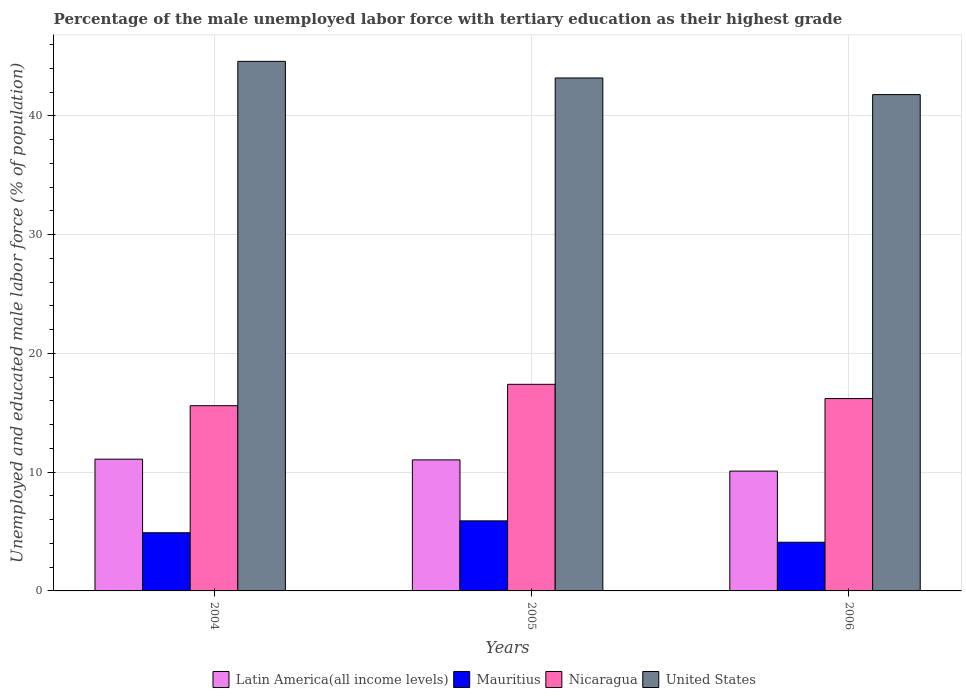How many different coloured bars are there?
Ensure brevity in your answer.  4. How many groups of bars are there?
Offer a very short reply. 3. How many bars are there on the 2nd tick from the left?
Provide a succinct answer. 4. What is the percentage of the unemployed male labor force with tertiary education in Mauritius in 2005?
Ensure brevity in your answer.  5.9. Across all years, what is the maximum percentage of the unemployed male labor force with tertiary education in Nicaragua?
Your answer should be compact. 17.4. Across all years, what is the minimum percentage of the unemployed male labor force with tertiary education in United States?
Keep it short and to the point. 41.8. In which year was the percentage of the unemployed male labor force with tertiary education in Mauritius minimum?
Your answer should be compact. 2006. What is the total percentage of the unemployed male labor force with tertiary education in Mauritius in the graph?
Your answer should be very brief. 14.9. What is the difference between the percentage of the unemployed male labor force with tertiary education in United States in 2005 and that in 2006?
Offer a very short reply. 1.4. What is the difference between the percentage of the unemployed male labor force with tertiary education in United States in 2005 and the percentage of the unemployed male labor force with tertiary education in Nicaragua in 2004?
Your answer should be compact. 27.6. What is the average percentage of the unemployed male labor force with tertiary education in Latin America(all income levels) per year?
Provide a succinct answer. 10.74. In the year 2006, what is the difference between the percentage of the unemployed male labor force with tertiary education in Mauritius and percentage of the unemployed male labor force with tertiary education in Nicaragua?
Make the answer very short. -12.1. In how many years, is the percentage of the unemployed male labor force with tertiary education in Latin America(all income levels) greater than 32 %?
Offer a very short reply. 0. What is the ratio of the percentage of the unemployed male labor force with tertiary education in United States in 2005 to that in 2006?
Provide a succinct answer. 1.03. Is the percentage of the unemployed male labor force with tertiary education in Mauritius in 2004 less than that in 2006?
Your answer should be compact. No. What is the difference between the highest and the second highest percentage of the unemployed male labor force with tertiary education in United States?
Your response must be concise. 1.4. What is the difference between the highest and the lowest percentage of the unemployed male labor force with tertiary education in Latin America(all income levels)?
Offer a terse response. 1. In how many years, is the percentage of the unemployed male labor force with tertiary education in United States greater than the average percentage of the unemployed male labor force with tertiary education in United States taken over all years?
Your answer should be very brief. 2. Is the sum of the percentage of the unemployed male labor force with tertiary education in United States in 2004 and 2006 greater than the maximum percentage of the unemployed male labor force with tertiary education in Nicaragua across all years?
Make the answer very short. Yes. Is it the case that in every year, the sum of the percentage of the unemployed male labor force with tertiary education in Latin America(all income levels) and percentage of the unemployed male labor force with tertiary education in Mauritius is greater than the sum of percentage of the unemployed male labor force with tertiary education in United States and percentage of the unemployed male labor force with tertiary education in Nicaragua?
Offer a very short reply. No. What does the 1st bar from the left in 2004 represents?
Make the answer very short. Latin America(all income levels). What does the 3rd bar from the right in 2005 represents?
Provide a succinct answer. Mauritius. Are all the bars in the graph horizontal?
Give a very brief answer. No. How many years are there in the graph?
Offer a terse response. 3. Does the graph contain any zero values?
Offer a very short reply. No. Where does the legend appear in the graph?
Make the answer very short. Bottom center. How are the legend labels stacked?
Provide a succinct answer. Horizontal. What is the title of the graph?
Give a very brief answer. Percentage of the male unemployed labor force with tertiary education as their highest grade. Does "Middle East & North Africa (all income levels)" appear as one of the legend labels in the graph?
Keep it short and to the point. No. What is the label or title of the X-axis?
Your answer should be compact. Years. What is the label or title of the Y-axis?
Your answer should be very brief. Unemployed and educated male labor force (% of population). What is the Unemployed and educated male labor force (% of population) in Latin America(all income levels) in 2004?
Provide a short and direct response. 11.1. What is the Unemployed and educated male labor force (% of population) in Mauritius in 2004?
Your answer should be very brief. 4.9. What is the Unemployed and educated male labor force (% of population) of Nicaragua in 2004?
Make the answer very short. 15.6. What is the Unemployed and educated male labor force (% of population) in United States in 2004?
Your answer should be compact. 44.6. What is the Unemployed and educated male labor force (% of population) of Latin America(all income levels) in 2005?
Offer a terse response. 11.03. What is the Unemployed and educated male labor force (% of population) in Mauritius in 2005?
Make the answer very short. 5.9. What is the Unemployed and educated male labor force (% of population) in Nicaragua in 2005?
Ensure brevity in your answer.  17.4. What is the Unemployed and educated male labor force (% of population) in United States in 2005?
Provide a short and direct response. 43.2. What is the Unemployed and educated male labor force (% of population) of Latin America(all income levels) in 2006?
Make the answer very short. 10.09. What is the Unemployed and educated male labor force (% of population) of Mauritius in 2006?
Keep it short and to the point. 4.1. What is the Unemployed and educated male labor force (% of population) in Nicaragua in 2006?
Ensure brevity in your answer.  16.2. What is the Unemployed and educated male labor force (% of population) in United States in 2006?
Provide a succinct answer. 41.8. Across all years, what is the maximum Unemployed and educated male labor force (% of population) of Latin America(all income levels)?
Offer a terse response. 11.1. Across all years, what is the maximum Unemployed and educated male labor force (% of population) in Mauritius?
Provide a succinct answer. 5.9. Across all years, what is the maximum Unemployed and educated male labor force (% of population) in Nicaragua?
Your answer should be compact. 17.4. Across all years, what is the maximum Unemployed and educated male labor force (% of population) of United States?
Make the answer very short. 44.6. Across all years, what is the minimum Unemployed and educated male labor force (% of population) of Latin America(all income levels)?
Provide a short and direct response. 10.09. Across all years, what is the minimum Unemployed and educated male labor force (% of population) in Mauritius?
Provide a short and direct response. 4.1. Across all years, what is the minimum Unemployed and educated male labor force (% of population) of Nicaragua?
Your answer should be compact. 15.6. Across all years, what is the minimum Unemployed and educated male labor force (% of population) of United States?
Your answer should be very brief. 41.8. What is the total Unemployed and educated male labor force (% of population) in Latin America(all income levels) in the graph?
Your response must be concise. 32.22. What is the total Unemployed and educated male labor force (% of population) of Nicaragua in the graph?
Provide a succinct answer. 49.2. What is the total Unemployed and educated male labor force (% of population) of United States in the graph?
Provide a short and direct response. 129.6. What is the difference between the Unemployed and educated male labor force (% of population) of Latin America(all income levels) in 2004 and that in 2005?
Your answer should be very brief. 0.06. What is the difference between the Unemployed and educated male labor force (% of population) in Mauritius in 2004 and that in 2005?
Make the answer very short. -1. What is the difference between the Unemployed and educated male labor force (% of population) in Nicaragua in 2004 and that in 2005?
Make the answer very short. -1.8. What is the difference between the Unemployed and educated male labor force (% of population) in United States in 2004 and that in 2005?
Ensure brevity in your answer.  1.4. What is the difference between the Unemployed and educated male labor force (% of population) in Latin America(all income levels) in 2004 and that in 2006?
Ensure brevity in your answer.  1. What is the difference between the Unemployed and educated male labor force (% of population) of Latin America(all income levels) in 2005 and that in 2006?
Provide a short and direct response. 0.94. What is the difference between the Unemployed and educated male labor force (% of population) of Mauritius in 2005 and that in 2006?
Give a very brief answer. 1.8. What is the difference between the Unemployed and educated male labor force (% of population) in Latin America(all income levels) in 2004 and the Unemployed and educated male labor force (% of population) in Mauritius in 2005?
Provide a succinct answer. 5.2. What is the difference between the Unemployed and educated male labor force (% of population) of Latin America(all income levels) in 2004 and the Unemployed and educated male labor force (% of population) of Nicaragua in 2005?
Provide a succinct answer. -6.3. What is the difference between the Unemployed and educated male labor force (% of population) in Latin America(all income levels) in 2004 and the Unemployed and educated male labor force (% of population) in United States in 2005?
Ensure brevity in your answer.  -32.1. What is the difference between the Unemployed and educated male labor force (% of population) in Mauritius in 2004 and the Unemployed and educated male labor force (% of population) in United States in 2005?
Offer a terse response. -38.3. What is the difference between the Unemployed and educated male labor force (% of population) in Nicaragua in 2004 and the Unemployed and educated male labor force (% of population) in United States in 2005?
Provide a short and direct response. -27.6. What is the difference between the Unemployed and educated male labor force (% of population) of Latin America(all income levels) in 2004 and the Unemployed and educated male labor force (% of population) of Mauritius in 2006?
Provide a short and direct response. 7. What is the difference between the Unemployed and educated male labor force (% of population) of Latin America(all income levels) in 2004 and the Unemployed and educated male labor force (% of population) of Nicaragua in 2006?
Ensure brevity in your answer.  -5.1. What is the difference between the Unemployed and educated male labor force (% of population) of Latin America(all income levels) in 2004 and the Unemployed and educated male labor force (% of population) of United States in 2006?
Offer a terse response. -30.7. What is the difference between the Unemployed and educated male labor force (% of population) in Mauritius in 2004 and the Unemployed and educated male labor force (% of population) in Nicaragua in 2006?
Offer a very short reply. -11.3. What is the difference between the Unemployed and educated male labor force (% of population) in Mauritius in 2004 and the Unemployed and educated male labor force (% of population) in United States in 2006?
Your response must be concise. -36.9. What is the difference between the Unemployed and educated male labor force (% of population) of Nicaragua in 2004 and the Unemployed and educated male labor force (% of population) of United States in 2006?
Your answer should be compact. -26.2. What is the difference between the Unemployed and educated male labor force (% of population) of Latin America(all income levels) in 2005 and the Unemployed and educated male labor force (% of population) of Mauritius in 2006?
Keep it short and to the point. 6.93. What is the difference between the Unemployed and educated male labor force (% of population) of Latin America(all income levels) in 2005 and the Unemployed and educated male labor force (% of population) of Nicaragua in 2006?
Offer a very short reply. -5.17. What is the difference between the Unemployed and educated male labor force (% of population) in Latin America(all income levels) in 2005 and the Unemployed and educated male labor force (% of population) in United States in 2006?
Keep it short and to the point. -30.77. What is the difference between the Unemployed and educated male labor force (% of population) in Mauritius in 2005 and the Unemployed and educated male labor force (% of population) in Nicaragua in 2006?
Your answer should be compact. -10.3. What is the difference between the Unemployed and educated male labor force (% of population) of Mauritius in 2005 and the Unemployed and educated male labor force (% of population) of United States in 2006?
Your answer should be compact. -35.9. What is the difference between the Unemployed and educated male labor force (% of population) in Nicaragua in 2005 and the Unemployed and educated male labor force (% of population) in United States in 2006?
Offer a terse response. -24.4. What is the average Unemployed and educated male labor force (% of population) in Latin America(all income levels) per year?
Your answer should be very brief. 10.74. What is the average Unemployed and educated male labor force (% of population) of Mauritius per year?
Ensure brevity in your answer.  4.97. What is the average Unemployed and educated male labor force (% of population) in Nicaragua per year?
Your answer should be very brief. 16.4. What is the average Unemployed and educated male labor force (% of population) in United States per year?
Your answer should be compact. 43.2. In the year 2004, what is the difference between the Unemployed and educated male labor force (% of population) of Latin America(all income levels) and Unemployed and educated male labor force (% of population) of Mauritius?
Keep it short and to the point. 6.2. In the year 2004, what is the difference between the Unemployed and educated male labor force (% of population) in Latin America(all income levels) and Unemployed and educated male labor force (% of population) in Nicaragua?
Make the answer very short. -4.5. In the year 2004, what is the difference between the Unemployed and educated male labor force (% of population) of Latin America(all income levels) and Unemployed and educated male labor force (% of population) of United States?
Provide a short and direct response. -33.5. In the year 2004, what is the difference between the Unemployed and educated male labor force (% of population) in Mauritius and Unemployed and educated male labor force (% of population) in Nicaragua?
Your answer should be very brief. -10.7. In the year 2004, what is the difference between the Unemployed and educated male labor force (% of population) in Mauritius and Unemployed and educated male labor force (% of population) in United States?
Your answer should be compact. -39.7. In the year 2004, what is the difference between the Unemployed and educated male labor force (% of population) in Nicaragua and Unemployed and educated male labor force (% of population) in United States?
Make the answer very short. -29. In the year 2005, what is the difference between the Unemployed and educated male labor force (% of population) in Latin America(all income levels) and Unemployed and educated male labor force (% of population) in Mauritius?
Ensure brevity in your answer.  5.13. In the year 2005, what is the difference between the Unemployed and educated male labor force (% of population) of Latin America(all income levels) and Unemployed and educated male labor force (% of population) of Nicaragua?
Keep it short and to the point. -6.37. In the year 2005, what is the difference between the Unemployed and educated male labor force (% of population) of Latin America(all income levels) and Unemployed and educated male labor force (% of population) of United States?
Ensure brevity in your answer.  -32.17. In the year 2005, what is the difference between the Unemployed and educated male labor force (% of population) in Mauritius and Unemployed and educated male labor force (% of population) in United States?
Your answer should be very brief. -37.3. In the year 2005, what is the difference between the Unemployed and educated male labor force (% of population) in Nicaragua and Unemployed and educated male labor force (% of population) in United States?
Provide a succinct answer. -25.8. In the year 2006, what is the difference between the Unemployed and educated male labor force (% of population) of Latin America(all income levels) and Unemployed and educated male labor force (% of population) of Mauritius?
Ensure brevity in your answer.  5.99. In the year 2006, what is the difference between the Unemployed and educated male labor force (% of population) in Latin America(all income levels) and Unemployed and educated male labor force (% of population) in Nicaragua?
Offer a terse response. -6.11. In the year 2006, what is the difference between the Unemployed and educated male labor force (% of population) in Latin America(all income levels) and Unemployed and educated male labor force (% of population) in United States?
Ensure brevity in your answer.  -31.71. In the year 2006, what is the difference between the Unemployed and educated male labor force (% of population) of Mauritius and Unemployed and educated male labor force (% of population) of United States?
Your response must be concise. -37.7. In the year 2006, what is the difference between the Unemployed and educated male labor force (% of population) of Nicaragua and Unemployed and educated male labor force (% of population) of United States?
Provide a succinct answer. -25.6. What is the ratio of the Unemployed and educated male labor force (% of population) in Mauritius in 2004 to that in 2005?
Provide a short and direct response. 0.83. What is the ratio of the Unemployed and educated male labor force (% of population) in Nicaragua in 2004 to that in 2005?
Offer a very short reply. 0.9. What is the ratio of the Unemployed and educated male labor force (% of population) in United States in 2004 to that in 2005?
Keep it short and to the point. 1.03. What is the ratio of the Unemployed and educated male labor force (% of population) of Latin America(all income levels) in 2004 to that in 2006?
Offer a terse response. 1.1. What is the ratio of the Unemployed and educated male labor force (% of population) of Mauritius in 2004 to that in 2006?
Give a very brief answer. 1.2. What is the ratio of the Unemployed and educated male labor force (% of population) in Nicaragua in 2004 to that in 2006?
Make the answer very short. 0.96. What is the ratio of the Unemployed and educated male labor force (% of population) in United States in 2004 to that in 2006?
Offer a terse response. 1.07. What is the ratio of the Unemployed and educated male labor force (% of population) of Latin America(all income levels) in 2005 to that in 2006?
Your answer should be compact. 1.09. What is the ratio of the Unemployed and educated male labor force (% of population) of Mauritius in 2005 to that in 2006?
Provide a short and direct response. 1.44. What is the ratio of the Unemployed and educated male labor force (% of population) in Nicaragua in 2005 to that in 2006?
Provide a short and direct response. 1.07. What is the ratio of the Unemployed and educated male labor force (% of population) in United States in 2005 to that in 2006?
Provide a short and direct response. 1.03. What is the difference between the highest and the second highest Unemployed and educated male labor force (% of population) in Latin America(all income levels)?
Offer a very short reply. 0.06. What is the difference between the highest and the lowest Unemployed and educated male labor force (% of population) in Mauritius?
Provide a short and direct response. 1.8. What is the difference between the highest and the lowest Unemployed and educated male labor force (% of population) in Nicaragua?
Give a very brief answer. 1.8. What is the difference between the highest and the lowest Unemployed and educated male labor force (% of population) in United States?
Your answer should be very brief. 2.8. 